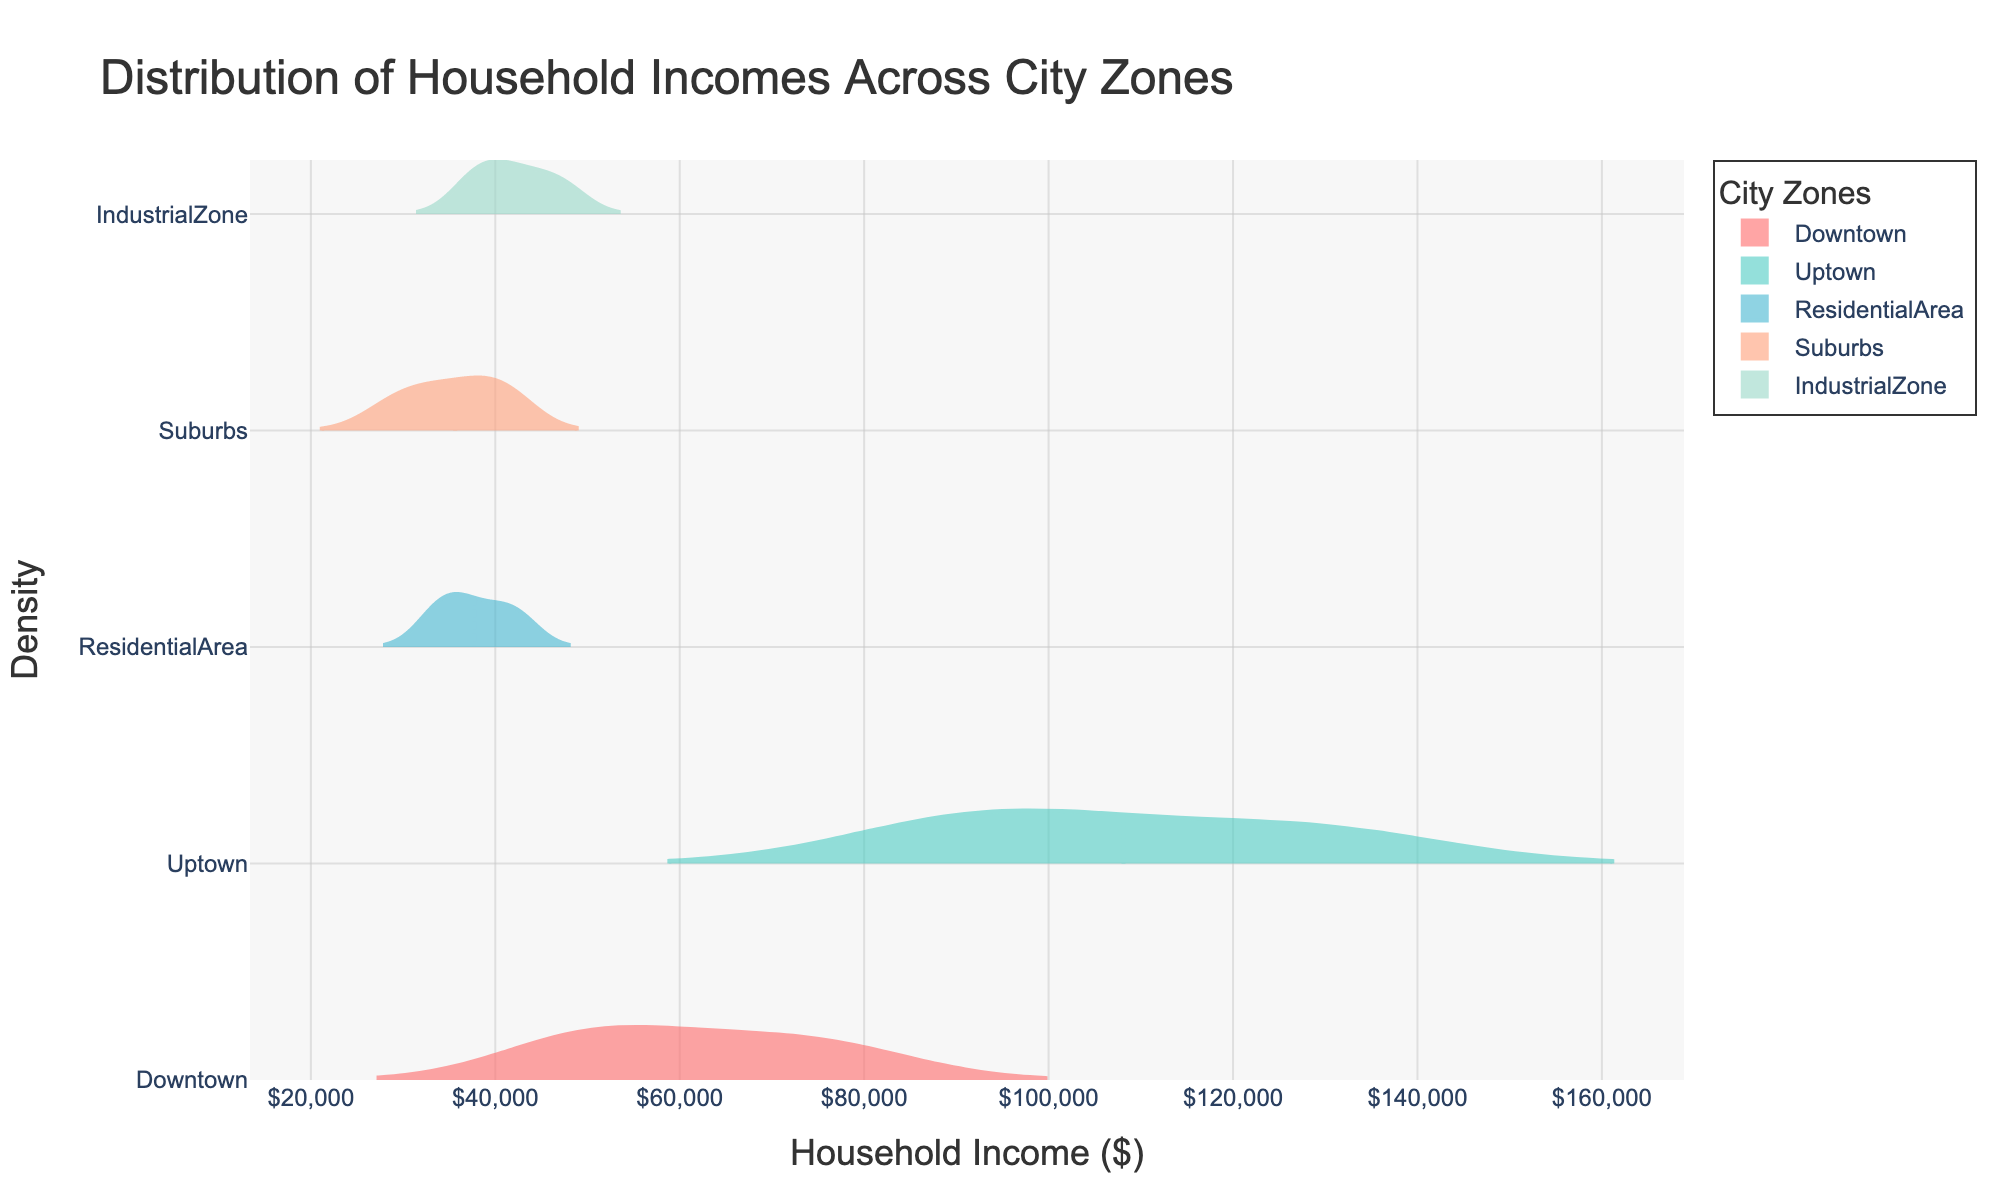What is the title of the figure? The title of the figure is displayed prominently at the top and summarizes the information presented. It provides context on what the visualization is about without needing to read the axes or legend.
Answer: Distribution of Household Incomes Across City Zones How is the data from different city zones visually distinguished in the figure? Each city zone is represented by a different line and fill color in the violin plot, making it easy to distinguish between zones. The legend on the right-hand side of the plot assigns a color to each zone.
Answer: Through color Which city zone has the highest mean household income according to the plot? The plot includes mean line indicators on each violin plot. You can identify the highest mean line visually and refer to the associated label in the legend.
Answer: Uptown Of all the zones, which one has the widest spread of household incomes? By examining the width of each violin plot, you can determine the spread of household incomes. The wider the plot, the greater the spread.
Answer: Downtown Between Residential Area and Suburbs, which zone has a higher median household income? Locate the mean line within each violin plot and compare their positions. The violin plot with the mean line further to the right has a higher median income.
Answer: Residential Area Comparing Downtown and Industrial Zone, which zone has lower variability in household incomes? Variability is represented by the width of the violin plot. The narrower the plot, the lower the variability.
Answer: Industrial Zone Is there any zone with household incomes exclusively above $50,000? Analyze the distribution within each violin plot. The zone without any density extending below $50,000 has all incomes above that threshold.
Answer: Uptown Which zone appears to have the lowest household income density peak? The density peak is where the violin plot is the widest. Identify the zone with the least pronounced peak.
Answer: Industrial Zone For which zone is the distribution most symmetrical around the mean? Symmetry can be observed by the shape of the violin plot around the center line. The more symmetrical the shape, the more evenly distributed the values are around the mean.
Answer: Industrial Zone 